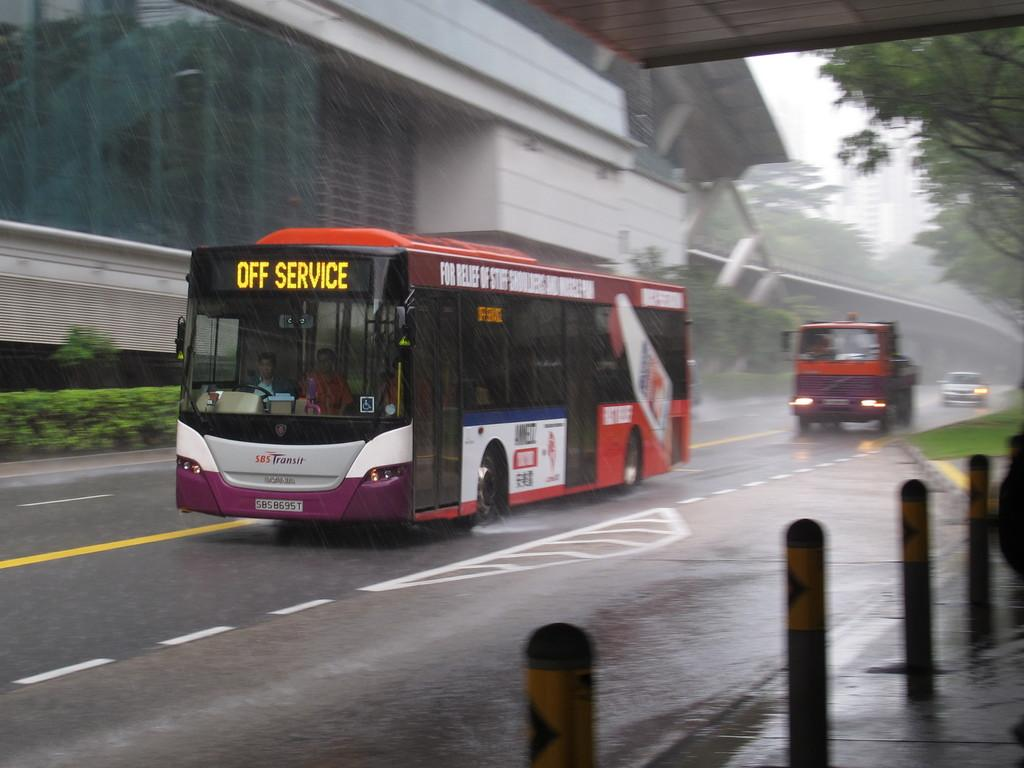What is the main subject of the image? The main subject of the image is a bus. What is the bus doing in the image? The bus is moving on the road in the image. What is the weather like in the image? It is raining in the image. What can be seen in the background of the image? There is a building in the background of the image. What type of vegetation is on the right side of the image? There are trees on the right side of the image. How many branches are visible on the bus in the image? There are no branches visible on the bus in the image; it is a vehicle, not a tree. What type of spade is being used by the passengers on the bus in the image? There are no spades present in the image, and passengers are not using any tools. 